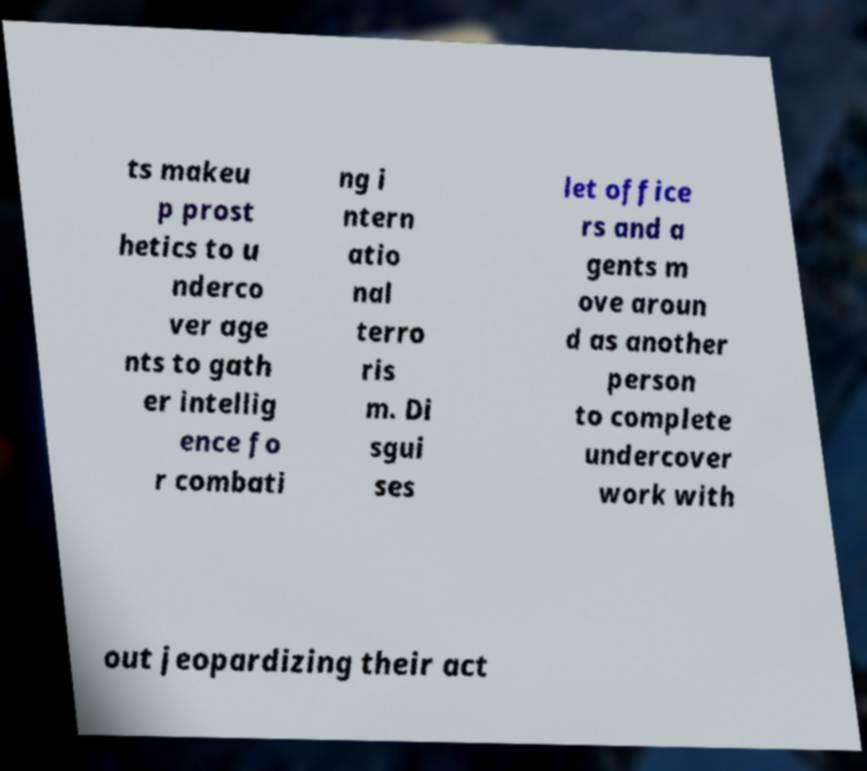For documentation purposes, I need the text within this image transcribed. Could you provide that? ts makeu p prost hetics to u nderco ver age nts to gath er intellig ence fo r combati ng i ntern atio nal terro ris m. Di sgui ses let office rs and a gents m ove aroun d as another person to complete undercover work with out jeopardizing their act 